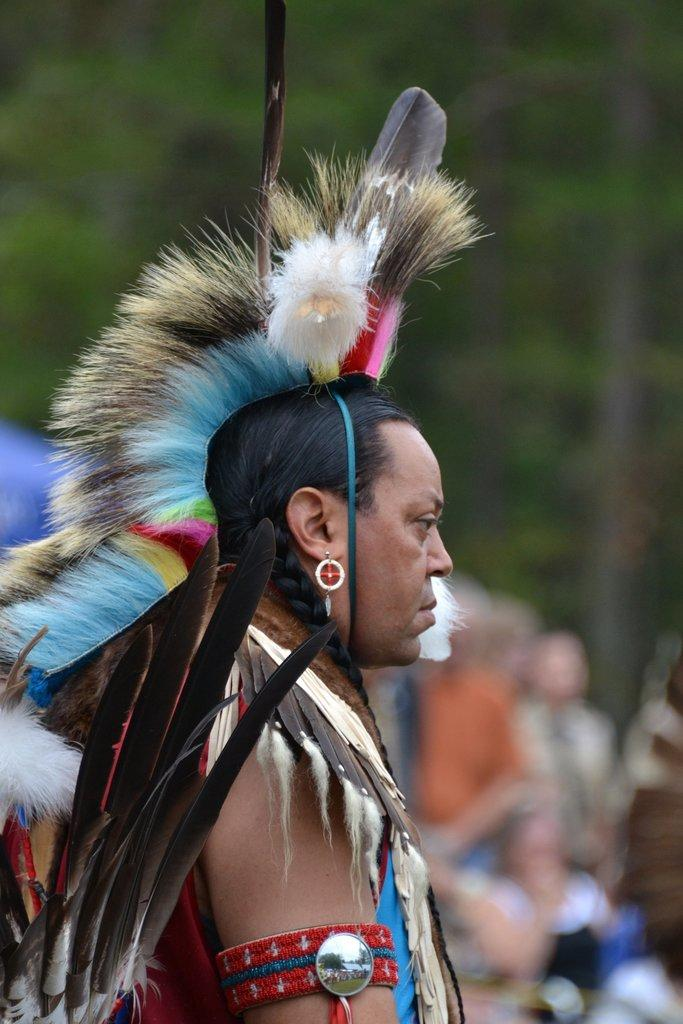What is the main subject of the image? There is a man in the image. What is the man wearing in the image? The man is wearing a costume in the image. Where is the man positioned in the image? The man is standing in the front of the image. Can you describe the background of the image? The background of the image is blurry. What reason does the man in the image have for holding a sign? There is no sign present in the image, so it cannot be determined if the man has a reason for holding one. 